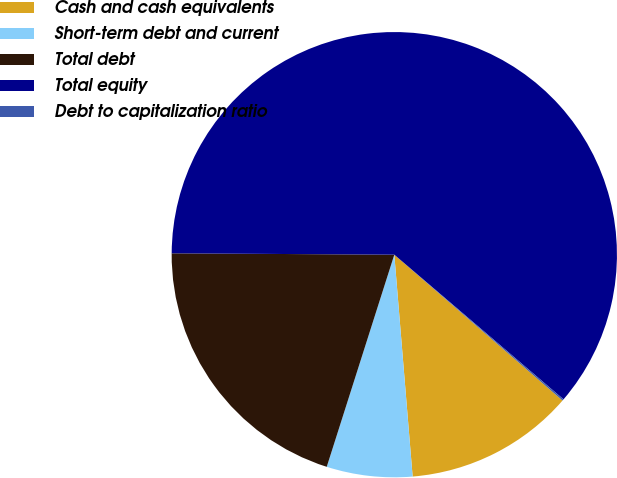Convert chart to OTSL. <chart><loc_0><loc_0><loc_500><loc_500><pie_chart><fcel>Cash and cash equivalents<fcel>Short-term debt and current<fcel>Total debt<fcel>Total equity<fcel>Debt to capitalization ratio<nl><fcel>12.32%<fcel>6.22%<fcel>20.19%<fcel>61.16%<fcel>0.11%<nl></chart> 